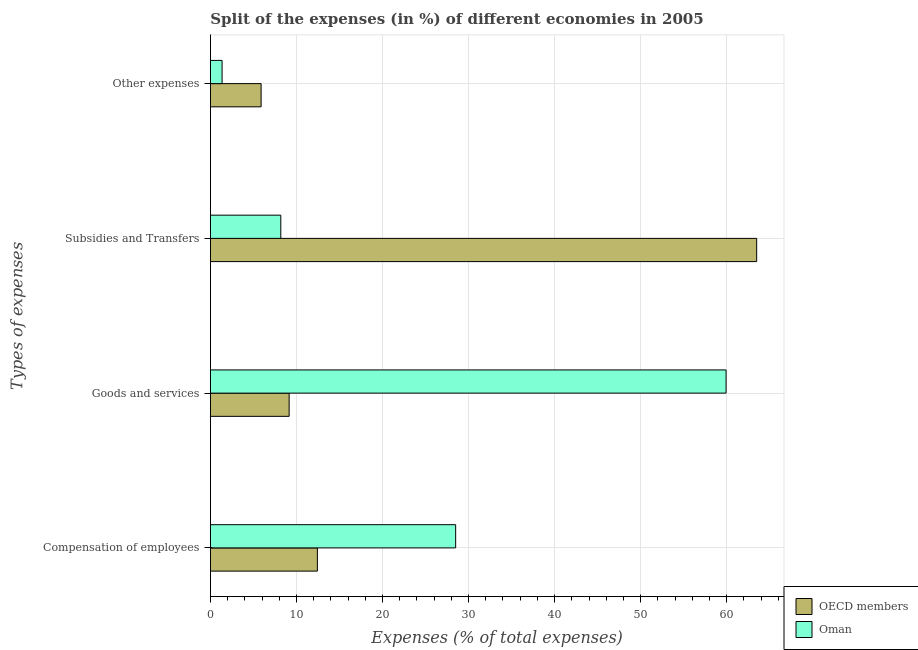How many different coloured bars are there?
Keep it short and to the point. 2. How many groups of bars are there?
Offer a very short reply. 4. Are the number of bars on each tick of the Y-axis equal?
Your answer should be very brief. Yes. How many bars are there on the 3rd tick from the bottom?
Provide a succinct answer. 2. What is the label of the 4th group of bars from the top?
Offer a terse response. Compensation of employees. What is the percentage of amount spent on goods and services in OECD members?
Your answer should be compact. 9.15. Across all countries, what is the maximum percentage of amount spent on goods and services?
Provide a short and direct response. 59.93. Across all countries, what is the minimum percentage of amount spent on goods and services?
Your answer should be compact. 9.15. What is the total percentage of amount spent on other expenses in the graph?
Your answer should be very brief. 7.25. What is the difference between the percentage of amount spent on subsidies in Oman and that in OECD members?
Your answer should be compact. -55.3. What is the difference between the percentage of amount spent on compensation of employees in OECD members and the percentage of amount spent on subsidies in Oman?
Give a very brief answer. 4.25. What is the average percentage of amount spent on other expenses per country?
Give a very brief answer. 3.63. What is the difference between the percentage of amount spent on compensation of employees and percentage of amount spent on goods and services in OECD members?
Provide a succinct answer. 3.28. What is the ratio of the percentage of amount spent on compensation of employees in OECD members to that in Oman?
Offer a very short reply. 0.44. Is the percentage of amount spent on compensation of employees in OECD members less than that in Oman?
Provide a succinct answer. Yes. Is the difference between the percentage of amount spent on other expenses in Oman and OECD members greater than the difference between the percentage of amount spent on goods and services in Oman and OECD members?
Keep it short and to the point. No. What is the difference between the highest and the second highest percentage of amount spent on goods and services?
Provide a succinct answer. 50.78. What is the difference between the highest and the lowest percentage of amount spent on compensation of employees?
Your response must be concise. 16.07. In how many countries, is the percentage of amount spent on other expenses greater than the average percentage of amount spent on other expenses taken over all countries?
Your response must be concise. 1. Is the sum of the percentage of amount spent on subsidies in Oman and OECD members greater than the maximum percentage of amount spent on other expenses across all countries?
Keep it short and to the point. Yes. Is it the case that in every country, the sum of the percentage of amount spent on subsidies and percentage of amount spent on compensation of employees is greater than the sum of percentage of amount spent on other expenses and percentage of amount spent on goods and services?
Ensure brevity in your answer.  No. What does the 1st bar from the top in Compensation of employees represents?
Give a very brief answer. Oman. What does the 1st bar from the bottom in Subsidies and Transfers represents?
Your response must be concise. OECD members. Is it the case that in every country, the sum of the percentage of amount spent on compensation of employees and percentage of amount spent on goods and services is greater than the percentage of amount spent on subsidies?
Your response must be concise. No. Are all the bars in the graph horizontal?
Provide a succinct answer. Yes. How many countries are there in the graph?
Keep it short and to the point. 2. Are the values on the major ticks of X-axis written in scientific E-notation?
Your answer should be compact. No. Does the graph contain any zero values?
Provide a short and direct response. No. Does the graph contain grids?
Provide a succinct answer. Yes. Where does the legend appear in the graph?
Provide a succinct answer. Bottom right. How are the legend labels stacked?
Keep it short and to the point. Vertical. What is the title of the graph?
Offer a terse response. Split of the expenses (in %) of different economies in 2005. What is the label or title of the X-axis?
Give a very brief answer. Expenses (% of total expenses). What is the label or title of the Y-axis?
Give a very brief answer. Types of expenses. What is the Expenses (% of total expenses) in OECD members in Compensation of employees?
Keep it short and to the point. 12.43. What is the Expenses (% of total expenses) of Oman in Compensation of employees?
Your response must be concise. 28.5. What is the Expenses (% of total expenses) of OECD members in Goods and services?
Make the answer very short. 9.15. What is the Expenses (% of total expenses) in Oman in Goods and services?
Provide a succinct answer. 59.93. What is the Expenses (% of total expenses) in OECD members in Subsidies and Transfers?
Ensure brevity in your answer.  63.48. What is the Expenses (% of total expenses) in Oman in Subsidies and Transfers?
Your answer should be very brief. 8.18. What is the Expenses (% of total expenses) in OECD members in Other expenses?
Offer a terse response. 5.89. What is the Expenses (% of total expenses) in Oman in Other expenses?
Make the answer very short. 1.36. Across all Types of expenses, what is the maximum Expenses (% of total expenses) of OECD members?
Provide a short and direct response. 63.48. Across all Types of expenses, what is the maximum Expenses (% of total expenses) in Oman?
Give a very brief answer. 59.93. Across all Types of expenses, what is the minimum Expenses (% of total expenses) of OECD members?
Offer a terse response. 5.89. Across all Types of expenses, what is the minimum Expenses (% of total expenses) of Oman?
Offer a very short reply. 1.36. What is the total Expenses (% of total expenses) of OECD members in the graph?
Your answer should be compact. 90.96. What is the total Expenses (% of total expenses) in Oman in the graph?
Make the answer very short. 97.97. What is the difference between the Expenses (% of total expenses) in OECD members in Compensation of employees and that in Goods and services?
Offer a very short reply. 3.28. What is the difference between the Expenses (% of total expenses) in Oman in Compensation of employees and that in Goods and services?
Your answer should be very brief. -31.43. What is the difference between the Expenses (% of total expenses) in OECD members in Compensation of employees and that in Subsidies and Transfers?
Keep it short and to the point. -51.05. What is the difference between the Expenses (% of total expenses) of Oman in Compensation of employees and that in Subsidies and Transfers?
Your answer should be very brief. 20.32. What is the difference between the Expenses (% of total expenses) of OECD members in Compensation of employees and that in Other expenses?
Your response must be concise. 6.54. What is the difference between the Expenses (% of total expenses) of Oman in Compensation of employees and that in Other expenses?
Offer a terse response. 27.14. What is the difference between the Expenses (% of total expenses) of OECD members in Goods and services and that in Subsidies and Transfers?
Offer a terse response. -54.33. What is the difference between the Expenses (% of total expenses) of Oman in Goods and services and that in Subsidies and Transfers?
Provide a short and direct response. 51.75. What is the difference between the Expenses (% of total expenses) in OECD members in Goods and services and that in Other expenses?
Your response must be concise. 3.26. What is the difference between the Expenses (% of total expenses) of Oman in Goods and services and that in Other expenses?
Offer a terse response. 58.57. What is the difference between the Expenses (% of total expenses) in OECD members in Subsidies and Transfers and that in Other expenses?
Your answer should be compact. 57.59. What is the difference between the Expenses (% of total expenses) in Oman in Subsidies and Transfers and that in Other expenses?
Your answer should be very brief. 6.82. What is the difference between the Expenses (% of total expenses) in OECD members in Compensation of employees and the Expenses (% of total expenses) in Oman in Goods and services?
Make the answer very short. -47.49. What is the difference between the Expenses (% of total expenses) in OECD members in Compensation of employees and the Expenses (% of total expenses) in Oman in Subsidies and Transfers?
Offer a terse response. 4.25. What is the difference between the Expenses (% of total expenses) of OECD members in Compensation of employees and the Expenses (% of total expenses) of Oman in Other expenses?
Give a very brief answer. 11.08. What is the difference between the Expenses (% of total expenses) in OECD members in Goods and services and the Expenses (% of total expenses) in Oman in Subsidies and Transfers?
Your answer should be compact. 0.97. What is the difference between the Expenses (% of total expenses) of OECD members in Goods and services and the Expenses (% of total expenses) of Oman in Other expenses?
Give a very brief answer. 7.79. What is the difference between the Expenses (% of total expenses) of OECD members in Subsidies and Transfers and the Expenses (% of total expenses) of Oman in Other expenses?
Offer a very short reply. 62.12. What is the average Expenses (% of total expenses) of OECD members per Types of expenses?
Your answer should be compact. 22.74. What is the average Expenses (% of total expenses) in Oman per Types of expenses?
Your answer should be compact. 24.49. What is the difference between the Expenses (% of total expenses) in OECD members and Expenses (% of total expenses) in Oman in Compensation of employees?
Your response must be concise. -16.07. What is the difference between the Expenses (% of total expenses) in OECD members and Expenses (% of total expenses) in Oman in Goods and services?
Give a very brief answer. -50.78. What is the difference between the Expenses (% of total expenses) in OECD members and Expenses (% of total expenses) in Oman in Subsidies and Transfers?
Give a very brief answer. 55.3. What is the difference between the Expenses (% of total expenses) of OECD members and Expenses (% of total expenses) of Oman in Other expenses?
Give a very brief answer. 4.54. What is the ratio of the Expenses (% of total expenses) in OECD members in Compensation of employees to that in Goods and services?
Your answer should be very brief. 1.36. What is the ratio of the Expenses (% of total expenses) in Oman in Compensation of employees to that in Goods and services?
Ensure brevity in your answer.  0.48. What is the ratio of the Expenses (% of total expenses) in OECD members in Compensation of employees to that in Subsidies and Transfers?
Offer a very short reply. 0.2. What is the ratio of the Expenses (% of total expenses) of Oman in Compensation of employees to that in Subsidies and Transfers?
Offer a very short reply. 3.48. What is the ratio of the Expenses (% of total expenses) of OECD members in Compensation of employees to that in Other expenses?
Your response must be concise. 2.11. What is the ratio of the Expenses (% of total expenses) of Oman in Compensation of employees to that in Other expenses?
Your answer should be compact. 20.99. What is the ratio of the Expenses (% of total expenses) of OECD members in Goods and services to that in Subsidies and Transfers?
Give a very brief answer. 0.14. What is the ratio of the Expenses (% of total expenses) of Oman in Goods and services to that in Subsidies and Transfers?
Give a very brief answer. 7.32. What is the ratio of the Expenses (% of total expenses) in OECD members in Goods and services to that in Other expenses?
Make the answer very short. 1.55. What is the ratio of the Expenses (% of total expenses) of Oman in Goods and services to that in Other expenses?
Your answer should be compact. 44.13. What is the ratio of the Expenses (% of total expenses) of OECD members in Subsidies and Transfers to that in Other expenses?
Your answer should be very brief. 10.77. What is the ratio of the Expenses (% of total expenses) in Oman in Subsidies and Transfers to that in Other expenses?
Provide a short and direct response. 6.02. What is the difference between the highest and the second highest Expenses (% of total expenses) in OECD members?
Provide a succinct answer. 51.05. What is the difference between the highest and the second highest Expenses (% of total expenses) in Oman?
Offer a very short reply. 31.43. What is the difference between the highest and the lowest Expenses (% of total expenses) of OECD members?
Provide a short and direct response. 57.59. What is the difference between the highest and the lowest Expenses (% of total expenses) of Oman?
Your response must be concise. 58.57. 